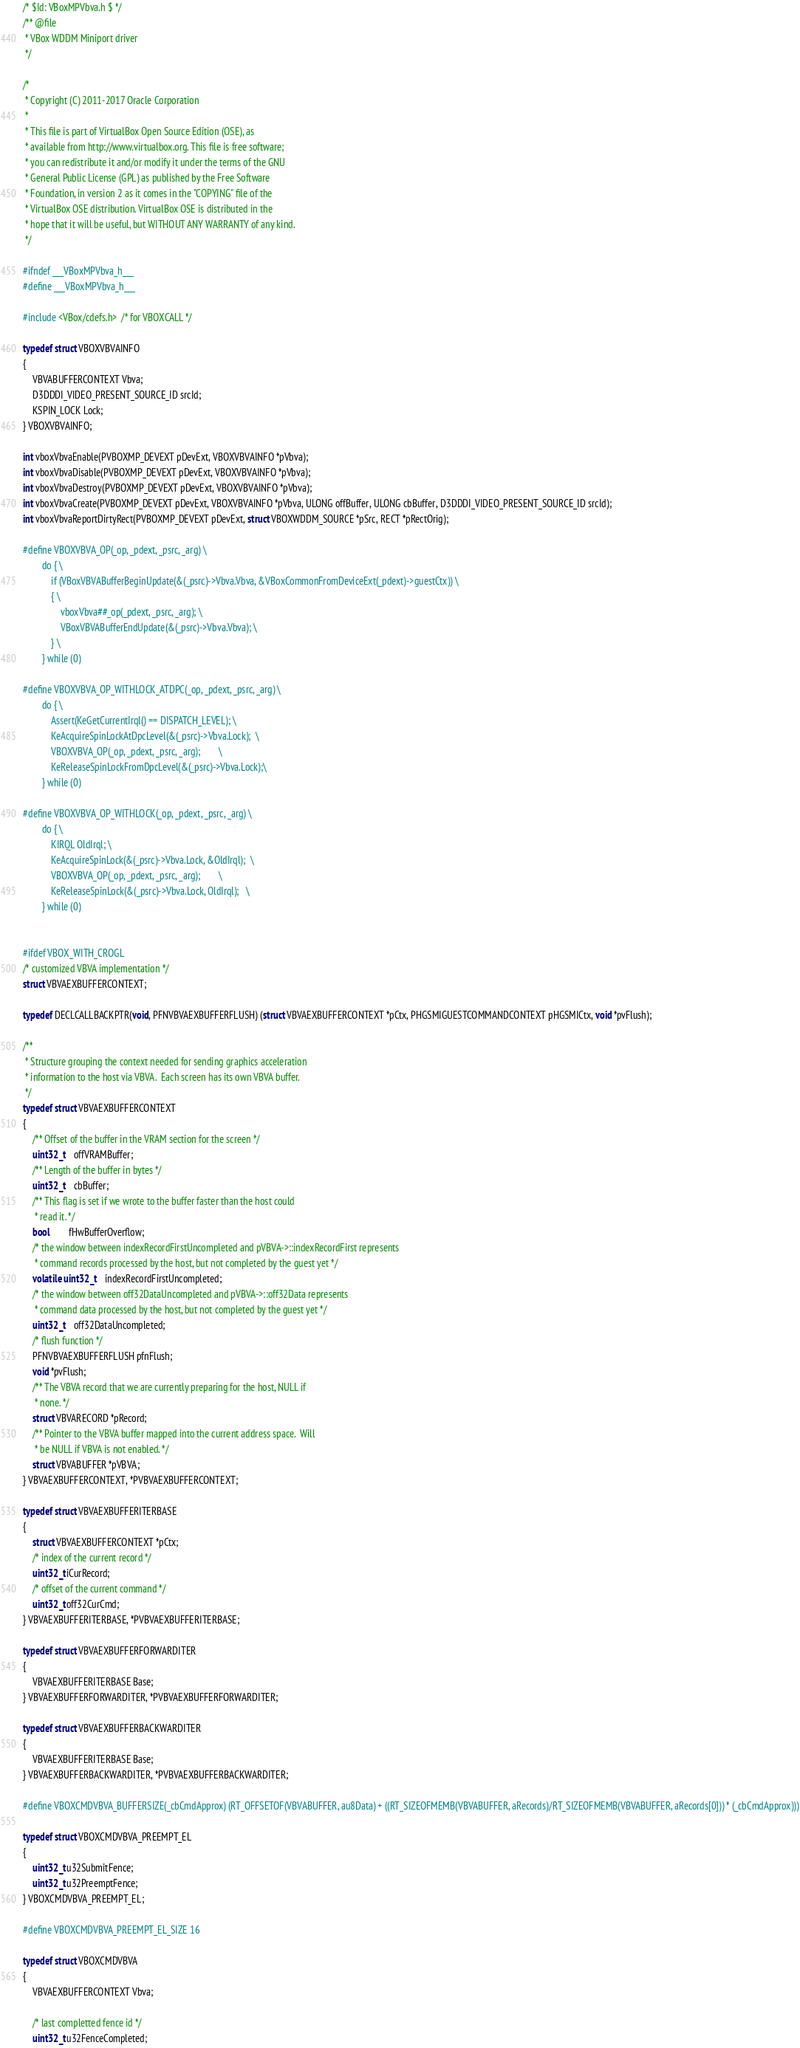<code> <loc_0><loc_0><loc_500><loc_500><_C_>/* $Id: VBoxMPVbva.h $ */
/** @file
 * VBox WDDM Miniport driver
 */

/*
 * Copyright (C) 2011-2017 Oracle Corporation
 *
 * This file is part of VirtualBox Open Source Edition (OSE), as
 * available from http://www.virtualbox.org. This file is free software;
 * you can redistribute it and/or modify it under the terms of the GNU
 * General Public License (GPL) as published by the Free Software
 * Foundation, in version 2 as it comes in the "COPYING" file of the
 * VirtualBox OSE distribution. VirtualBox OSE is distributed in the
 * hope that it will be useful, but WITHOUT ANY WARRANTY of any kind.
 */

#ifndef ___VBoxMPVbva_h___
#define ___VBoxMPVbva_h___

#include <VBox/cdefs.h>  /* for VBOXCALL */

typedef struct VBOXVBVAINFO
{
    VBVABUFFERCONTEXT Vbva;
    D3DDDI_VIDEO_PRESENT_SOURCE_ID srcId;
    KSPIN_LOCK Lock;
} VBOXVBVAINFO;

int vboxVbvaEnable(PVBOXMP_DEVEXT pDevExt, VBOXVBVAINFO *pVbva);
int vboxVbvaDisable(PVBOXMP_DEVEXT pDevExt, VBOXVBVAINFO *pVbva);
int vboxVbvaDestroy(PVBOXMP_DEVEXT pDevExt, VBOXVBVAINFO *pVbva);
int vboxVbvaCreate(PVBOXMP_DEVEXT pDevExt, VBOXVBVAINFO *pVbva, ULONG offBuffer, ULONG cbBuffer, D3DDDI_VIDEO_PRESENT_SOURCE_ID srcId);
int vboxVbvaReportDirtyRect(PVBOXMP_DEVEXT pDevExt, struct VBOXWDDM_SOURCE *pSrc, RECT *pRectOrig);

#define VBOXVBVA_OP(_op, _pdext, _psrc, _arg) \
        do { \
            if (VBoxVBVABufferBeginUpdate(&(_psrc)->Vbva.Vbva, &VBoxCommonFromDeviceExt(_pdext)->guestCtx)) \
            { \
                vboxVbva##_op(_pdext, _psrc, _arg); \
                VBoxVBVABufferEndUpdate(&(_psrc)->Vbva.Vbva); \
            } \
        } while (0)

#define VBOXVBVA_OP_WITHLOCK_ATDPC(_op, _pdext, _psrc, _arg) \
        do { \
            Assert(KeGetCurrentIrql() == DISPATCH_LEVEL); \
            KeAcquireSpinLockAtDpcLevel(&(_psrc)->Vbva.Lock);  \
            VBOXVBVA_OP(_op, _pdext, _psrc, _arg);        \
            KeReleaseSpinLockFromDpcLevel(&(_psrc)->Vbva.Lock);\
        } while (0)

#define VBOXVBVA_OP_WITHLOCK(_op, _pdext, _psrc, _arg) \
        do { \
            KIRQL OldIrql; \
            KeAcquireSpinLock(&(_psrc)->Vbva.Lock, &OldIrql);  \
            VBOXVBVA_OP(_op, _pdext, _psrc, _arg);        \
            KeReleaseSpinLock(&(_psrc)->Vbva.Lock, OldIrql);   \
        } while (0)


#ifdef VBOX_WITH_CROGL
/* customized VBVA implementation */
struct VBVAEXBUFFERCONTEXT;

typedef DECLCALLBACKPTR(void, PFNVBVAEXBUFFERFLUSH) (struct VBVAEXBUFFERCONTEXT *pCtx, PHGSMIGUESTCOMMANDCONTEXT pHGSMICtx, void *pvFlush);

/**
 * Structure grouping the context needed for sending graphics acceleration
 * information to the host via VBVA.  Each screen has its own VBVA buffer.
 */
typedef struct VBVAEXBUFFERCONTEXT
{
    /** Offset of the buffer in the VRAM section for the screen */
    uint32_t    offVRAMBuffer;
    /** Length of the buffer in bytes */
    uint32_t    cbBuffer;
    /** This flag is set if we wrote to the buffer faster than the host could
     * read it. */
    bool        fHwBufferOverflow;
    /* the window between indexRecordFirstUncompleted and pVBVA->::indexRecordFirst represents
     * command records processed by the host, but not completed by the guest yet */
    volatile uint32_t    indexRecordFirstUncompleted;
    /* the window between off32DataUncompleted and pVBVA->::off32Data represents
     * command data processed by the host, but not completed by the guest yet */
    uint32_t    off32DataUncompleted;
    /* flush function */
    PFNVBVAEXBUFFERFLUSH pfnFlush;
    void *pvFlush;
    /** The VBVA record that we are currently preparing for the host, NULL if
     * none. */
    struct VBVARECORD *pRecord;
    /** Pointer to the VBVA buffer mapped into the current address space.  Will
     * be NULL if VBVA is not enabled. */
    struct VBVABUFFER *pVBVA;
} VBVAEXBUFFERCONTEXT, *PVBVAEXBUFFERCONTEXT;

typedef struct VBVAEXBUFFERITERBASE
{
    struct VBVAEXBUFFERCONTEXT *pCtx;
    /* index of the current record */
    uint32_t iCurRecord;
    /* offset of the current command */
    uint32_t off32CurCmd;
} VBVAEXBUFFERITERBASE, *PVBVAEXBUFFERITERBASE;

typedef struct VBVAEXBUFFERFORWARDITER
{
    VBVAEXBUFFERITERBASE Base;
} VBVAEXBUFFERFORWARDITER, *PVBVAEXBUFFERFORWARDITER;

typedef struct VBVAEXBUFFERBACKWARDITER
{
    VBVAEXBUFFERITERBASE Base;
} VBVAEXBUFFERBACKWARDITER, *PVBVAEXBUFFERBACKWARDITER;

#define VBOXCMDVBVA_BUFFERSIZE(_cbCmdApprox) (RT_OFFSETOF(VBVABUFFER, au8Data) + ((RT_SIZEOFMEMB(VBVABUFFER, aRecords)/RT_SIZEOFMEMB(VBVABUFFER, aRecords[0])) * (_cbCmdApprox)))

typedef struct VBOXCMDVBVA_PREEMPT_EL
{
    uint32_t u32SubmitFence;
    uint32_t u32PreemptFence;
} VBOXCMDVBVA_PREEMPT_EL;

#define VBOXCMDVBVA_PREEMPT_EL_SIZE 16

typedef struct VBOXCMDVBVA
{
    VBVAEXBUFFERCONTEXT Vbva;

    /* last completted fence id */
    uint32_t u32FenceCompleted;</code> 